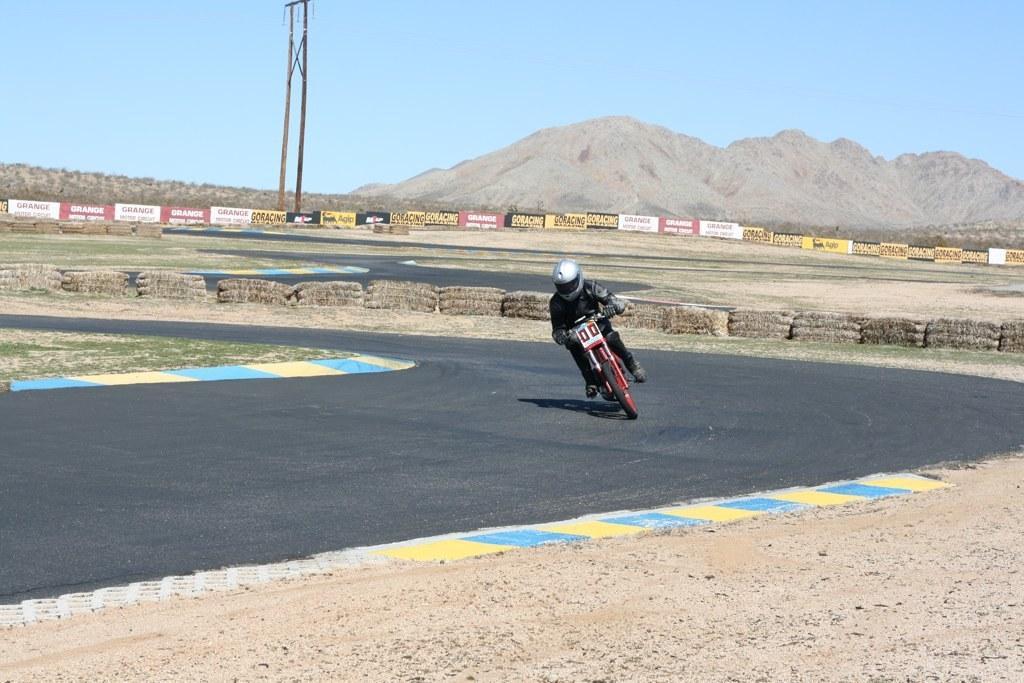Please provide a concise description of this image. In this image we can see a person riding motor vehicle on the road, hills, advertisement boards, poles and sky. 